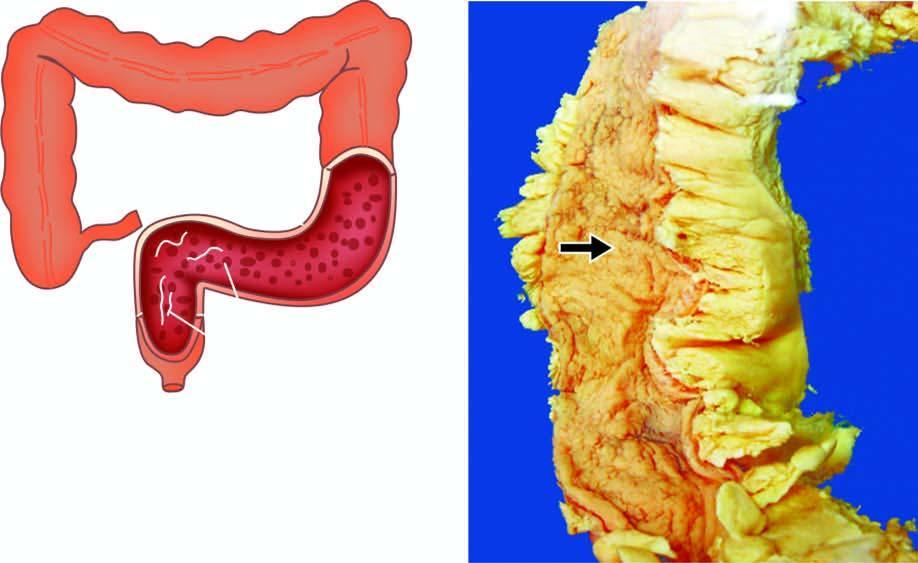re irregular nuclear folds lost giving 'garden-hose appearance '?
Answer the question using a single word or phrase. No 